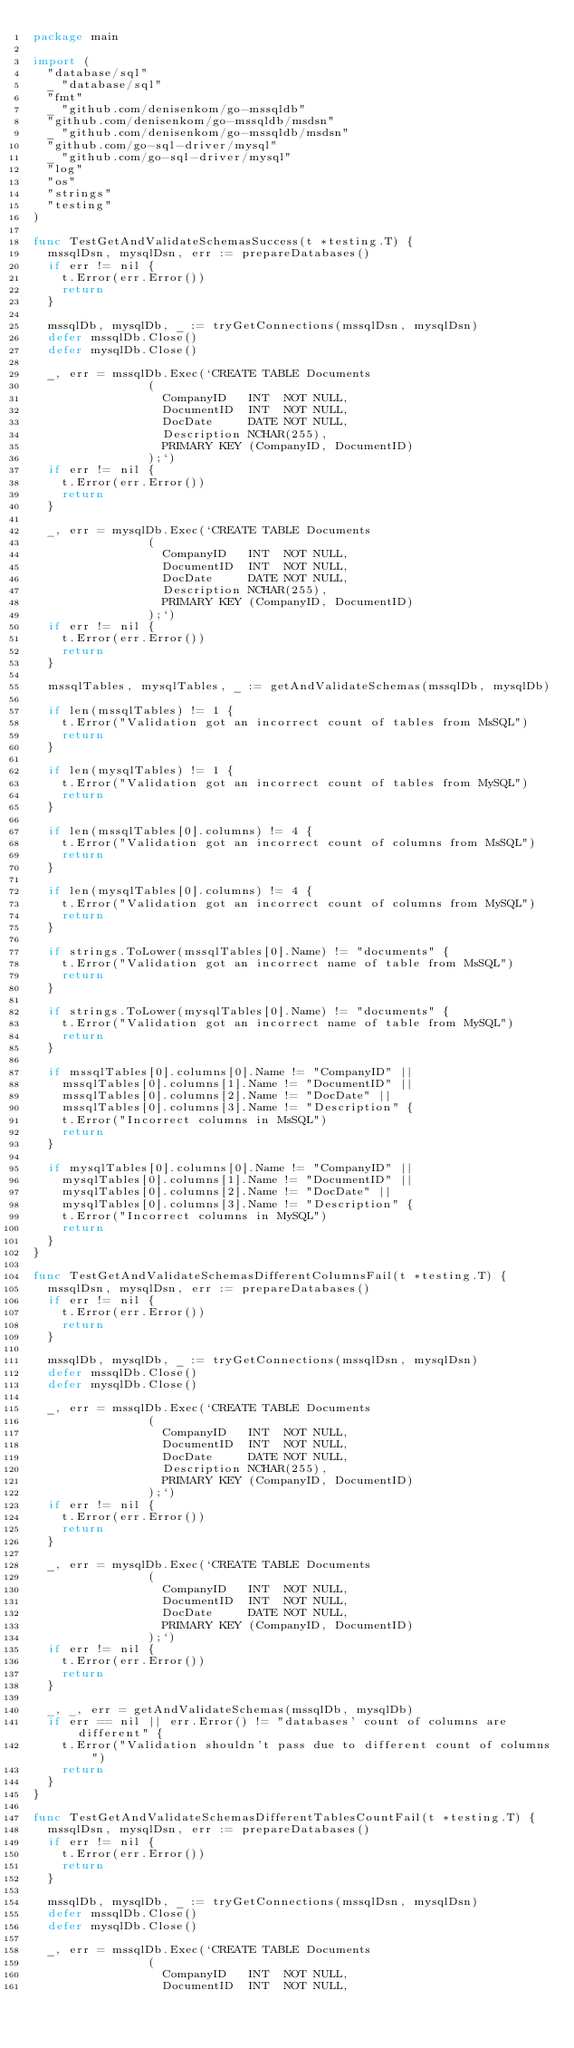Convert code to text. <code><loc_0><loc_0><loc_500><loc_500><_Go_>package main

import (
	"database/sql"
	_ "database/sql"
	"fmt"
	_ "github.com/denisenkom/go-mssqldb"
	"github.com/denisenkom/go-mssqldb/msdsn"
	_ "github.com/denisenkom/go-mssqldb/msdsn"
	"github.com/go-sql-driver/mysql"
	_ "github.com/go-sql-driver/mysql"
	"log"
	"os"
	"strings"
	"testing"
)

func TestGetAndValidateSchemasSuccess(t *testing.T) {
	mssqlDsn, mysqlDsn, err := prepareDatabases()
	if err != nil {
		t.Error(err.Error())
		return
	}

	mssqlDb, mysqlDb, _ := tryGetConnections(mssqlDsn, mysqlDsn)
	defer mssqlDb.Close()
	defer mysqlDb.Close()

	_, err = mssqlDb.Exec(`CREATE TABLE Documents
								(
									CompanyID   INT  NOT NULL,
									DocumentID  INT  NOT NULL,
									DocDate     DATE NOT NULL,
									Description NCHAR(255),
									PRIMARY KEY (CompanyID, DocumentID)
								);`)
	if err != nil {
		t.Error(err.Error())
		return
	}

	_, err = mysqlDb.Exec(`CREATE TABLE Documents
								(
									CompanyID   INT  NOT NULL,
									DocumentID  INT  NOT NULL,
									DocDate     DATE NOT NULL,
									Description NCHAR(255),
									PRIMARY KEY (CompanyID, DocumentID)
								);`)
	if err != nil {
		t.Error(err.Error())
		return
	}

	mssqlTables, mysqlTables, _ := getAndValidateSchemas(mssqlDb, mysqlDb)

	if len(mssqlTables) != 1 {
		t.Error("Validation got an incorrect count of tables from MsSQL")
		return
	}

	if len(mysqlTables) != 1 {
		t.Error("Validation got an incorrect count of tables from MySQL")
		return
	}

	if len(mssqlTables[0].columns) != 4 {
		t.Error("Validation got an incorrect count of columns from MsSQL")
		return
	}

	if len(mysqlTables[0].columns) != 4 {
		t.Error("Validation got an incorrect count of columns from MySQL")
		return
	}

	if strings.ToLower(mssqlTables[0].Name) != "documents" {
		t.Error("Validation got an incorrect name of table from MsSQL")
		return
	}

	if strings.ToLower(mysqlTables[0].Name) != "documents" {
		t.Error("Validation got an incorrect name of table from MySQL")
		return
	}

	if mssqlTables[0].columns[0].Name != "CompanyID" ||
		mssqlTables[0].columns[1].Name != "DocumentID" ||
		mssqlTables[0].columns[2].Name != "DocDate" ||
		mssqlTables[0].columns[3].Name != "Description" {
		t.Error("Incorrect columns in MsSQL")
		return
	}

	if mysqlTables[0].columns[0].Name != "CompanyID" ||
		mysqlTables[0].columns[1].Name != "DocumentID" ||
		mysqlTables[0].columns[2].Name != "DocDate" ||
		mysqlTables[0].columns[3].Name != "Description" {
		t.Error("Incorrect columns in MySQL")
		return
	}
}

func TestGetAndValidateSchemasDifferentColumnsFail(t *testing.T) {
	mssqlDsn, mysqlDsn, err := prepareDatabases()
	if err != nil {
		t.Error(err.Error())
		return
	}

	mssqlDb, mysqlDb, _ := tryGetConnections(mssqlDsn, mysqlDsn)
	defer mssqlDb.Close()
	defer mysqlDb.Close()

	_, err = mssqlDb.Exec(`CREATE TABLE Documents
								(
									CompanyID   INT  NOT NULL,
									DocumentID  INT  NOT NULL,
									DocDate     DATE NOT NULL,
									Description NCHAR(255),
									PRIMARY KEY (CompanyID, DocumentID)
								);`)
	if err != nil {
		t.Error(err.Error())
		return
	}

	_, err = mysqlDb.Exec(`CREATE TABLE Documents
								(
									CompanyID   INT  NOT NULL,
									DocumentID  INT  NOT NULL,
									DocDate     DATE NOT NULL,
									PRIMARY KEY (CompanyID, DocumentID)
								);`)
	if err != nil {
		t.Error(err.Error())
		return
	}

	_, _, err = getAndValidateSchemas(mssqlDb, mysqlDb)
	if err == nil || err.Error() != "databases' count of columns are different" {
		t.Error("Validation shouldn't pass due to different count of columns")
		return
	}
}

func TestGetAndValidateSchemasDifferentTablesCountFail(t *testing.T) {
	mssqlDsn, mysqlDsn, err := prepareDatabases()
	if err != nil {
		t.Error(err.Error())
		return
	}

	mssqlDb, mysqlDb, _ := tryGetConnections(mssqlDsn, mysqlDsn)
	defer mssqlDb.Close()
	defer mysqlDb.Close()

	_, err = mssqlDb.Exec(`CREATE TABLE Documents
								(
									CompanyID   INT  NOT NULL,
									DocumentID  INT  NOT NULL,</code> 